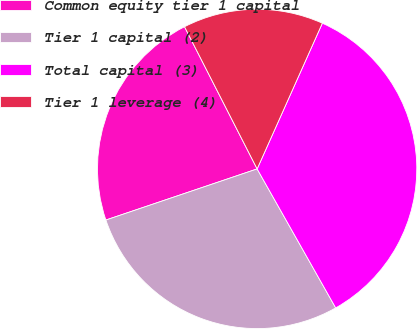<chart> <loc_0><loc_0><loc_500><loc_500><pie_chart><fcel>Common equity tier 1 capital<fcel>Tier 1 capital (2)<fcel>Total capital (3)<fcel>Tier 1 leverage (4)<nl><fcel>22.67%<fcel>28.0%<fcel>35.11%<fcel>14.21%<nl></chart> 